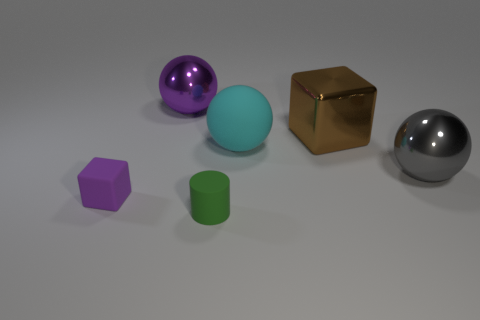Add 4 tiny yellow things. How many objects exist? 10 Subtract all blocks. How many objects are left? 4 Add 4 big brown metallic things. How many big brown metallic things exist? 5 Subtract 1 purple balls. How many objects are left? 5 Subtract all brown blocks. Subtract all big purple balls. How many objects are left? 4 Add 3 purple rubber things. How many purple rubber things are left? 4 